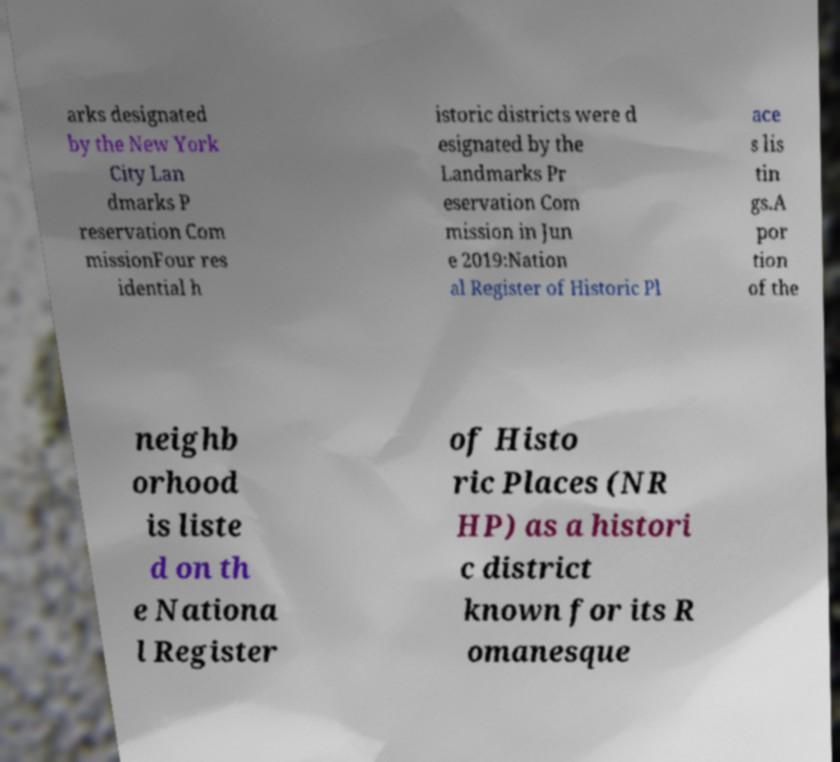Please read and relay the text visible in this image. What does it say? arks designated by the New York City Lan dmarks P reservation Com missionFour res idential h istoric districts were d esignated by the Landmarks Pr eservation Com mission in Jun e 2019:Nation al Register of Historic Pl ace s lis tin gs.A por tion of the neighb orhood is liste d on th e Nationa l Register of Histo ric Places (NR HP) as a histori c district known for its R omanesque 